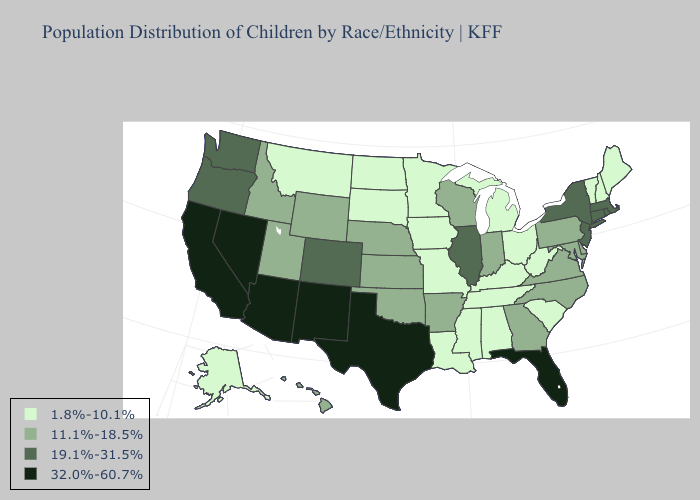What is the value of Alaska?
Short answer required. 1.8%-10.1%. Name the states that have a value in the range 19.1%-31.5%?
Answer briefly. Colorado, Connecticut, Illinois, Massachusetts, New Jersey, New York, Oregon, Rhode Island, Washington. Does Virginia have the lowest value in the USA?
Give a very brief answer. No. Among the states that border Oregon , does California have the highest value?
Write a very short answer. Yes. What is the highest value in the USA?
Answer briefly. 32.0%-60.7%. Name the states that have a value in the range 1.8%-10.1%?
Be succinct. Alabama, Alaska, Iowa, Kentucky, Louisiana, Maine, Michigan, Minnesota, Mississippi, Missouri, Montana, New Hampshire, North Dakota, Ohio, South Carolina, South Dakota, Tennessee, Vermont, West Virginia. Name the states that have a value in the range 1.8%-10.1%?
Be succinct. Alabama, Alaska, Iowa, Kentucky, Louisiana, Maine, Michigan, Minnesota, Mississippi, Missouri, Montana, New Hampshire, North Dakota, Ohio, South Carolina, South Dakota, Tennessee, Vermont, West Virginia. Which states have the lowest value in the Northeast?
Keep it brief. Maine, New Hampshire, Vermont. Among the states that border New York , does Pennsylvania have the lowest value?
Answer briefly. No. What is the value of Connecticut?
Concise answer only. 19.1%-31.5%. Which states have the lowest value in the USA?
Short answer required. Alabama, Alaska, Iowa, Kentucky, Louisiana, Maine, Michigan, Minnesota, Mississippi, Missouri, Montana, New Hampshire, North Dakota, Ohio, South Carolina, South Dakota, Tennessee, Vermont, West Virginia. Name the states that have a value in the range 32.0%-60.7%?
Give a very brief answer. Arizona, California, Florida, Nevada, New Mexico, Texas. What is the lowest value in states that border New Jersey?
Be succinct. 11.1%-18.5%. Among the states that border North Dakota , which have the lowest value?
Be succinct. Minnesota, Montana, South Dakota. 